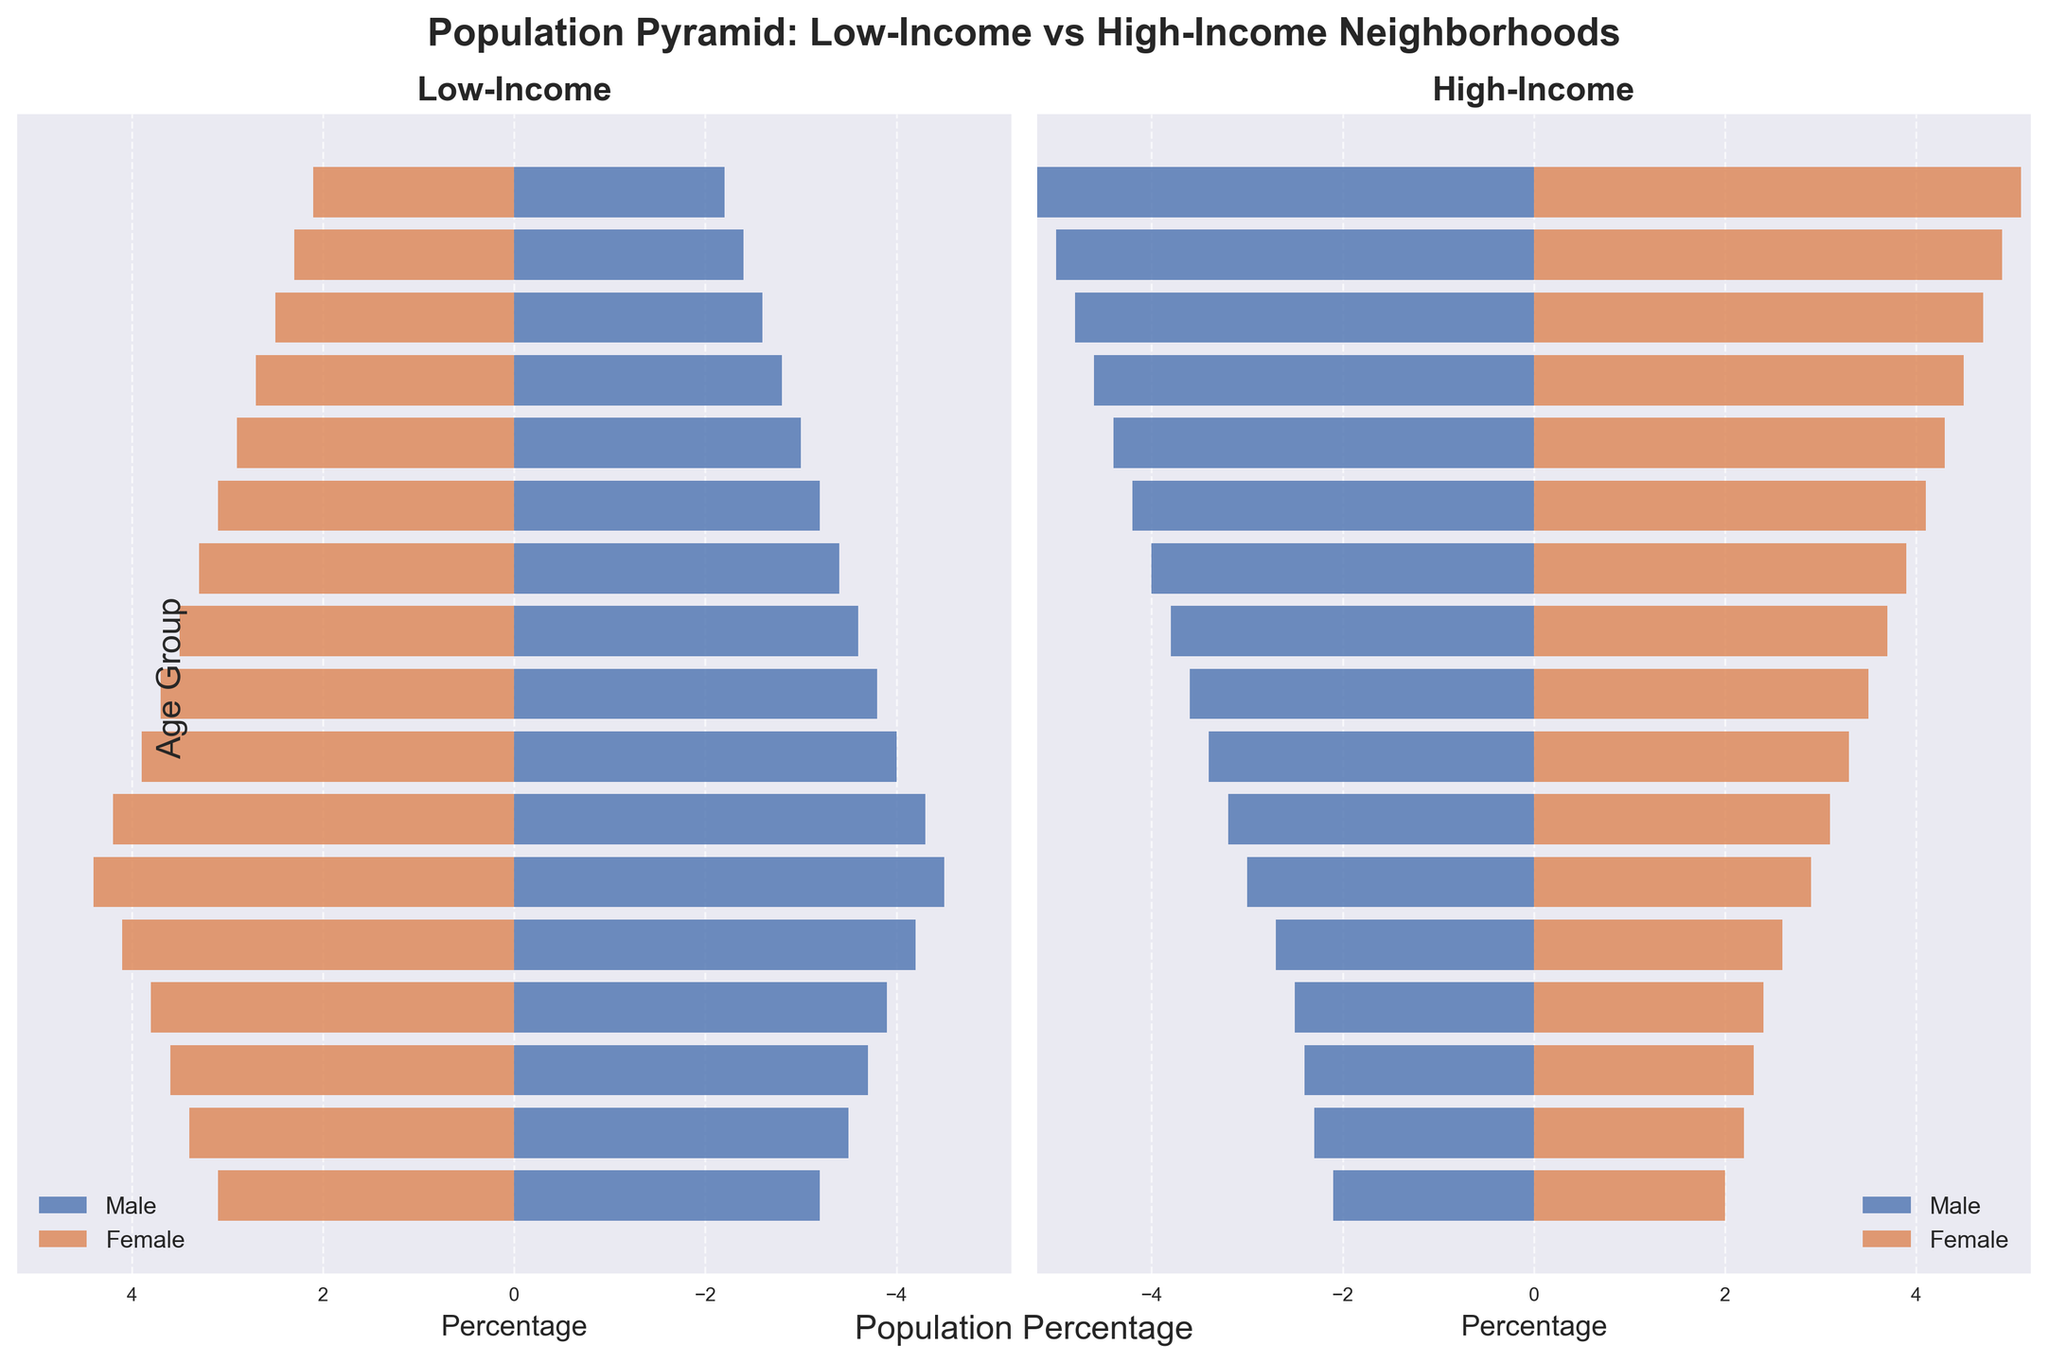Which age group has the highest percentage of males in low-income neighborhoods? By looking at the legend and the horizontal bars in the Low-Income plot, we can see that the 25-29 age group for males has the longest bar in the negative direction, indicating it has the highest percentage of males in low-income neighborhoods.
Answer: 25-29 Which gender has a higher percentage in the 60-64 age group in high-income neighborhoods? Compare the bar lengths for males and females in the 60-64 age group on the High-Income side of the pyramid. The female bar is longer, indicating a higher percentage.
Answer: Female What's the difference in percentage of males between the low-income and high-income neighborhoods in the 0-4 age group? Subtract the percentage of males in high-income neighborhoods (2.1) from the percentage of males in low-income neighborhoods (3.2). So, 3.2 - 2.1 = 1.1.
Answer: 1.1 In which income group do we see a higher percentage of people aged 45-49? Compare the total bar lengths for both males and females in the 45-49 age group across both income groups. The high-income total (3.8+3.7=7.5) is higher than the low-income total (3.6+3.5=7.1).
Answer: High-Income How does the distribution for males aged 80+ differ between low-income and high-income neighborhoods? Observe the lengths of the male bars for the 80+ age group. The high-income bar is longer indicating a higher percentage of males (5.2) compared to the low-income bar (2.2).
Answer: High-Income has a higher percentage What is the total percentage of people in the 30-34 age group in low-income neighborhoods? Add the percentage of males and females in the 30-34 age group in low-income neighborhoods: 4.3 + 4.2 = 8.5.
Answer: 8.5 Which gender and income group shows a steady increase in the percentage distribution from age 0-4 to 20-24? Observe the trend in the population bars from age group 0-4 to 20-24. Males in low-income neighborhoods show a steady increase in percentages.
Answer: Low-Income Males What age group has the highest percentage difference between females in low-income and high-income neighborhoods? Calculate the percentage differences for each age group: (0-4: 3.1-2.0=1.1, 5-9: 3.4-2.2=1.2, ..., 75-79: 2.3-4.9=2.6, 80+: 2.1-5.1=3.0). The highest difference is in the 80+ age group.
Answer: 80+ Is the percentage of females aged 55-59 higher in low-income or high-income neighborhoods? Compare the lengths of the bars for females aged 55-59 in both income groups. The bar for high-income females is longer, indicating a higher percentage.
Answer: High-Income 